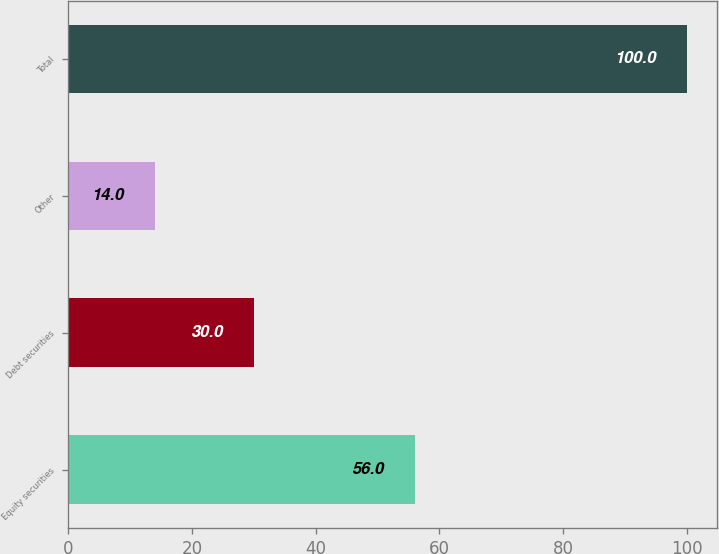<chart> <loc_0><loc_0><loc_500><loc_500><bar_chart><fcel>Equity securities<fcel>Debt securities<fcel>Other<fcel>Total<nl><fcel>56<fcel>30<fcel>14<fcel>100<nl></chart> 